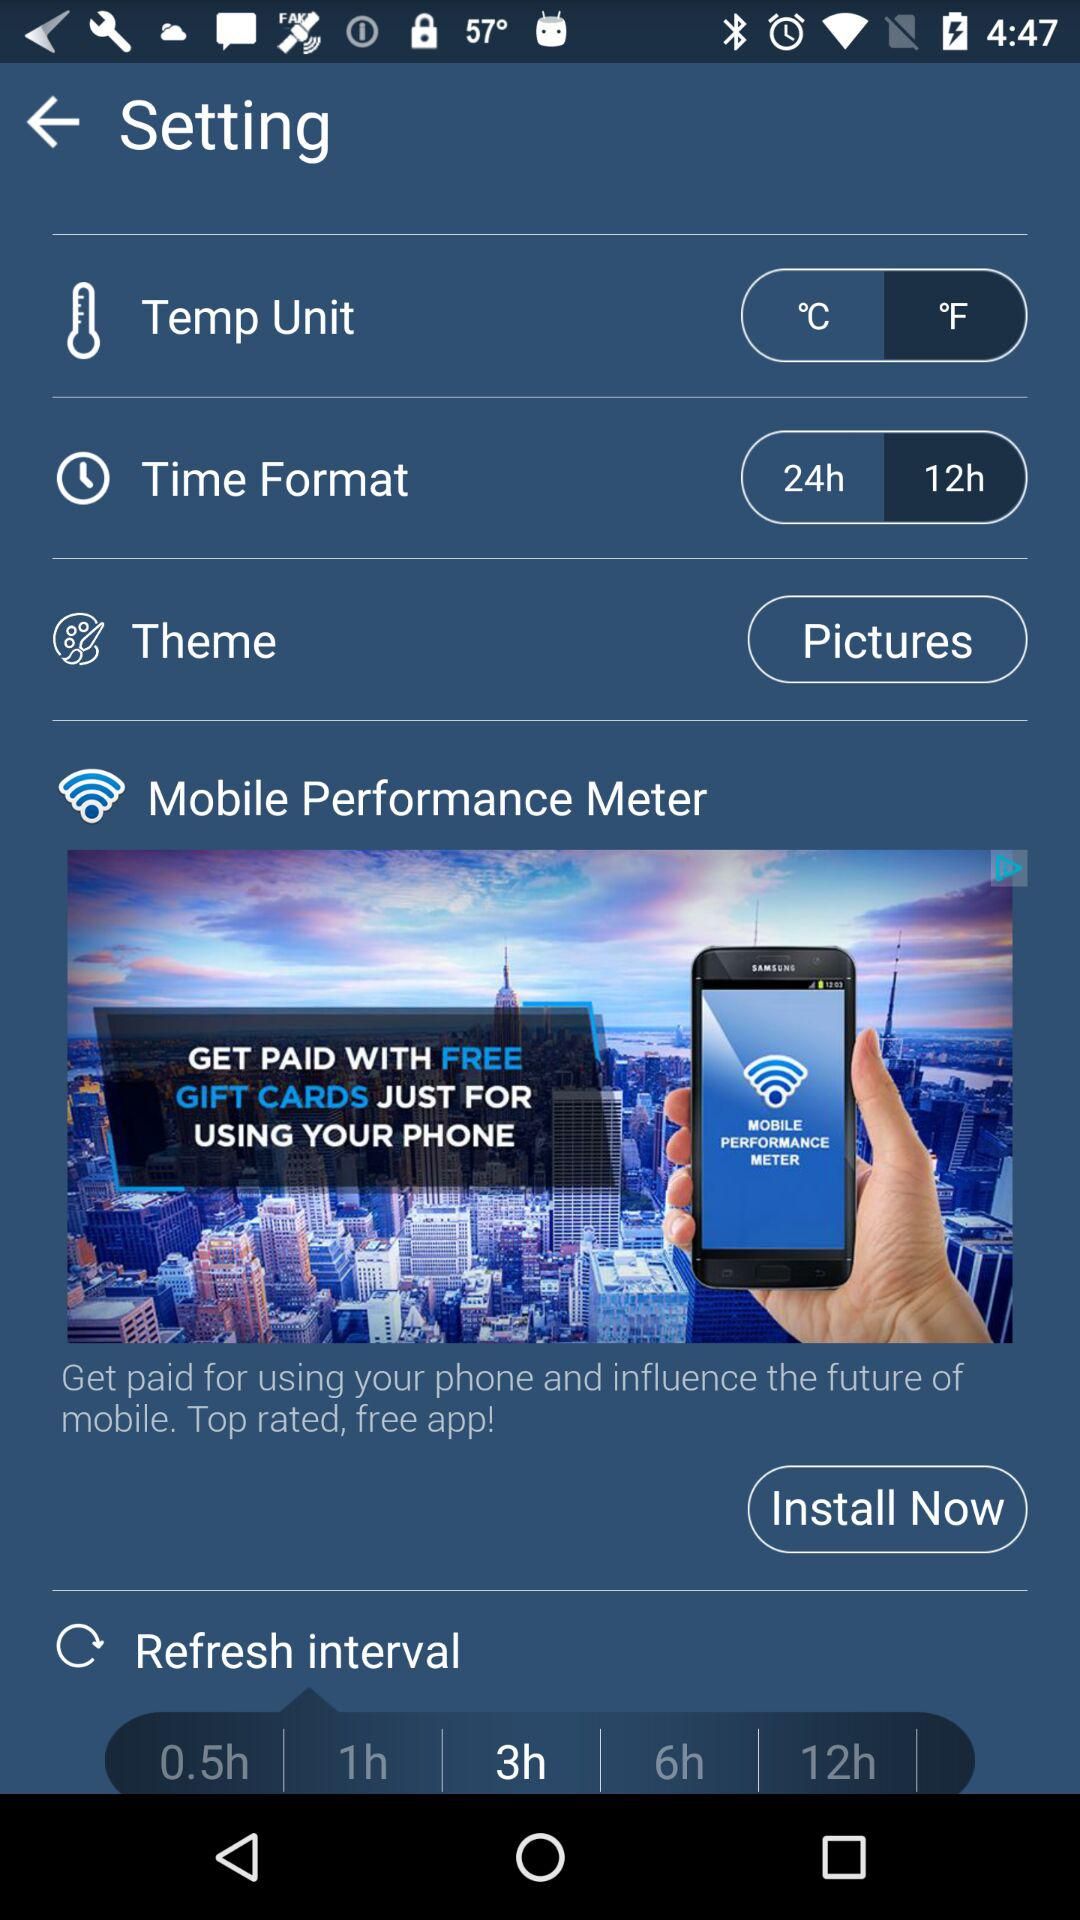Which two options are given in the time format setting? The two given options are "24h" and "12h". 